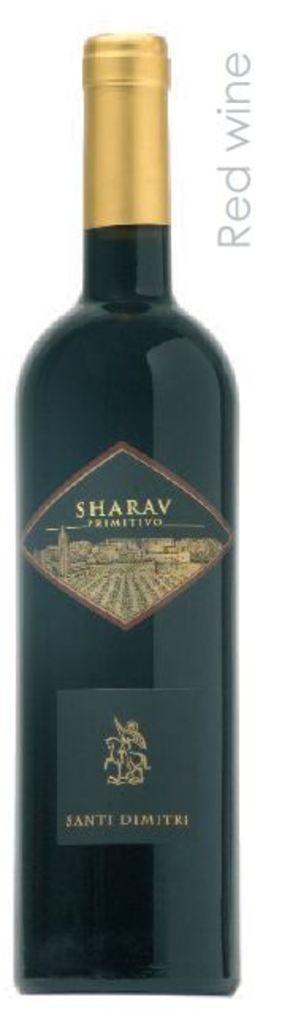<image>
Relay a brief, clear account of the picture shown. A bottle of red wine has a Sharav label on it. 